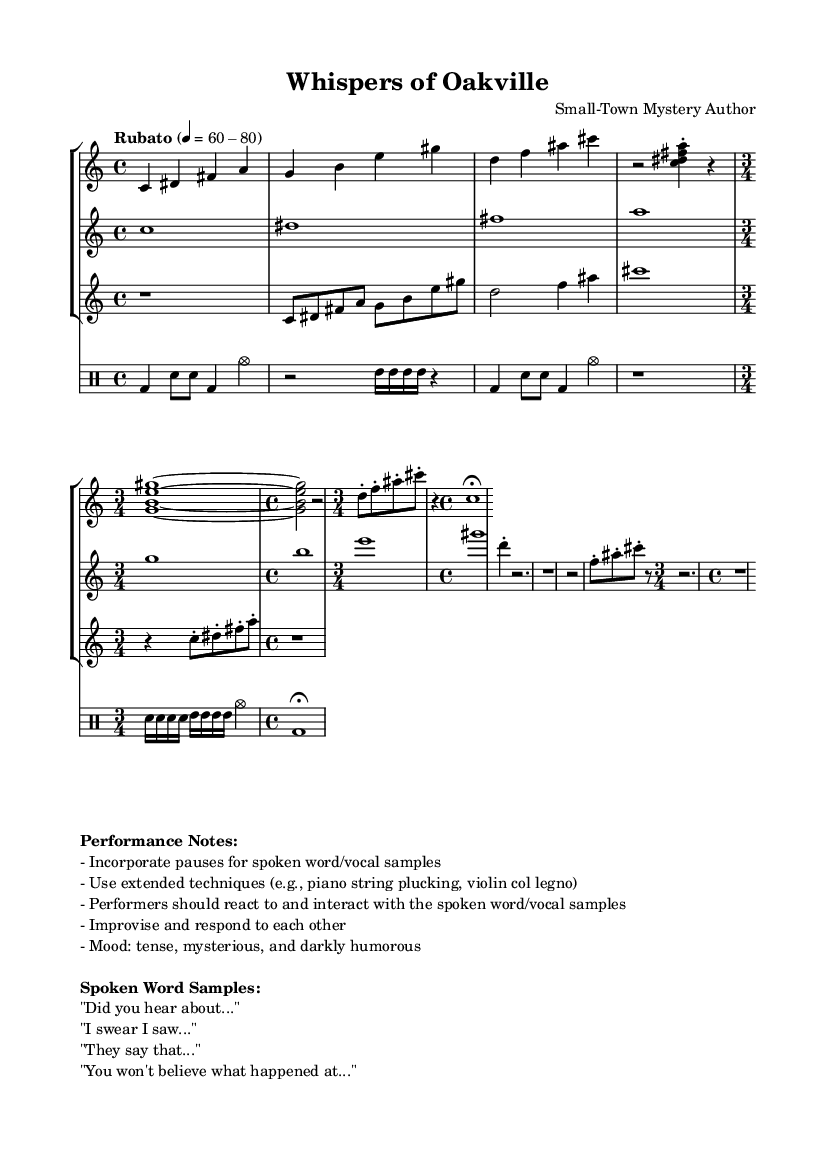What is the time signature of this music? The time signature is indicated as 4/4 primarily at the beginning with some measures switching to 3/4. This can be seen in the global context followed by specific inputs that still maintain a 4/4 structure.
Answer: 4/4, 3/4 What tempo marking is used in the piece? The tempo marking is "Rubato," which means a flexible tempo that allows for expressive timing. The actual beats given (60-80) suggest a range of speed but are part of the broader rubato indication.
Answer: Rubato How many instruments are included in this composition? The score includes three staves for piano, violin, and clarinet, as well as a separate DrumStaff for percussion. Thus, there are a total of four distinct parts.
Answer: Four What mood is suggested for the performance? The performance notes indicate a mood that is described as "tense, mysterious, and darkly humorous," providing performers with emotional guidance for interpretation.
Answer: Tense, mysterious, and darkly humorous What techniques are suggested for the performers? The performance notes mention using extended techniques like "piano string plucking" and "violin col legno." These techniques enhance the experimental nature of the piece.
Answer: Extended techniques 